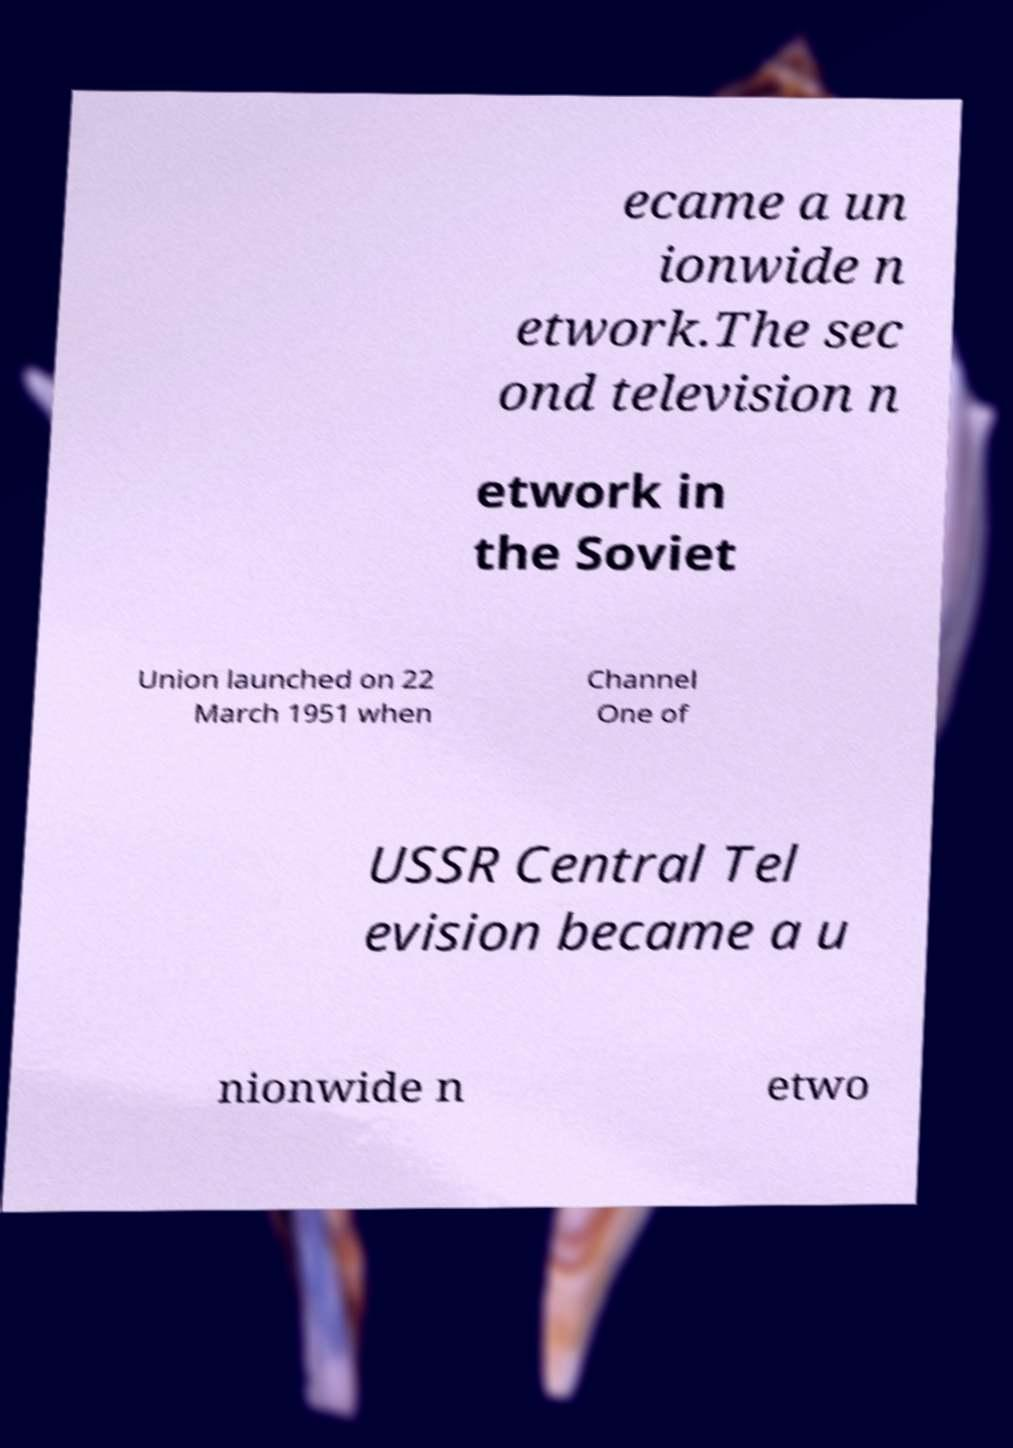Could you extract and type out the text from this image? ecame a un ionwide n etwork.The sec ond television n etwork in the Soviet Union launched on 22 March 1951 when Channel One of USSR Central Tel evision became a u nionwide n etwo 